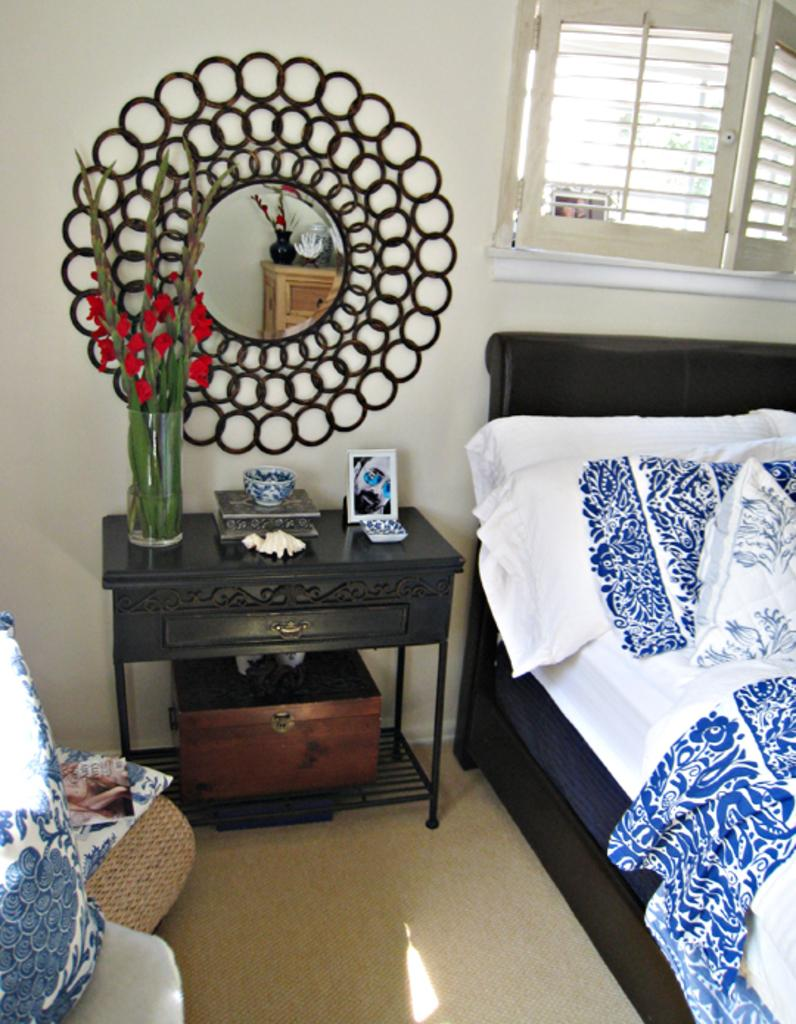What piece of furniture is present in the image? There is a bed in the image. What is placed on the bed? There is a pillow on the bed. What is hanging on the wall in the image? There is a mirror on the wall. What type of container holds the flowers in the image? The flowers are in a glass. What other piece of furniture can be seen in the image? There is a table in the image. Where is the crown placed in the image? There is no crown present in the image. How many clocks can be seen in the image? There are no clocks visible in the image. 